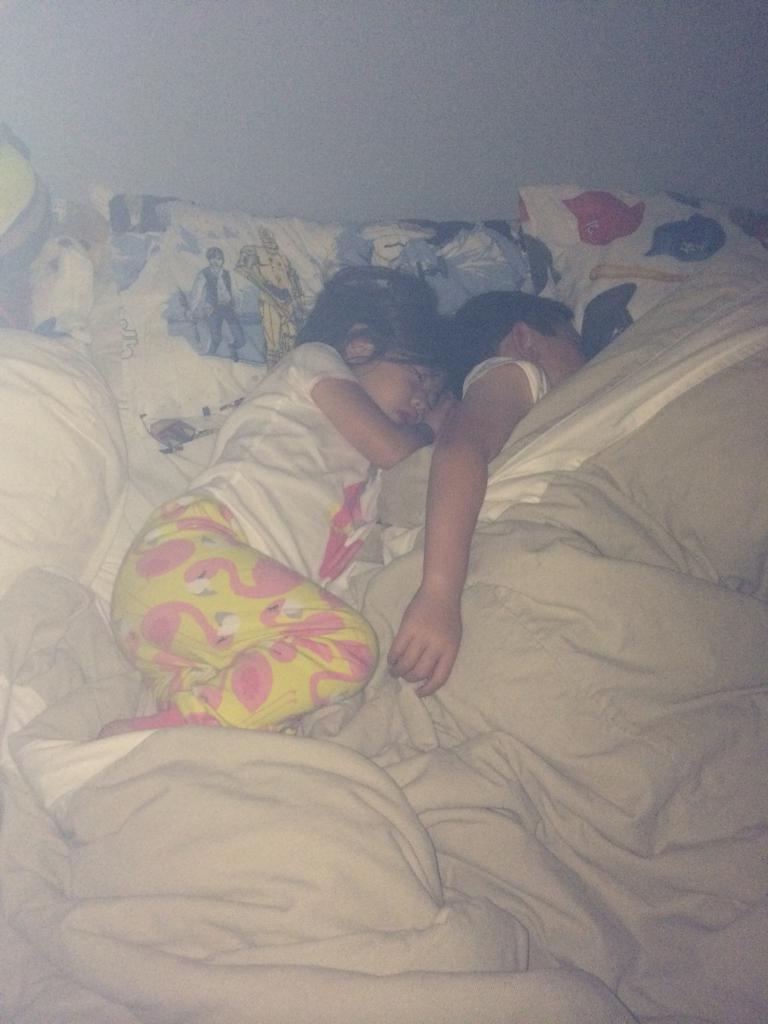How many children are in the image? There are two children in the image. What are the children doing in the image? The children are sleeping on a bed. What items are present on the bed to provide comfort? There are pillows present in the image. What covers the bed in the image? Bed sheets are visible in the image. What type of account do the children have in the image? There is no mention of an account in the image; it features two children sleeping on a bed. Are the children's brothers in the image? The provided facts do not mention the relationship between the children, so it cannot be determined if they are brothers. 